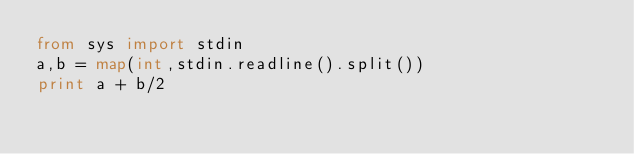Convert code to text. <code><loc_0><loc_0><loc_500><loc_500><_Python_>from sys import stdin
a,b = map(int,stdin.readline().split())
print a + b/2</code> 